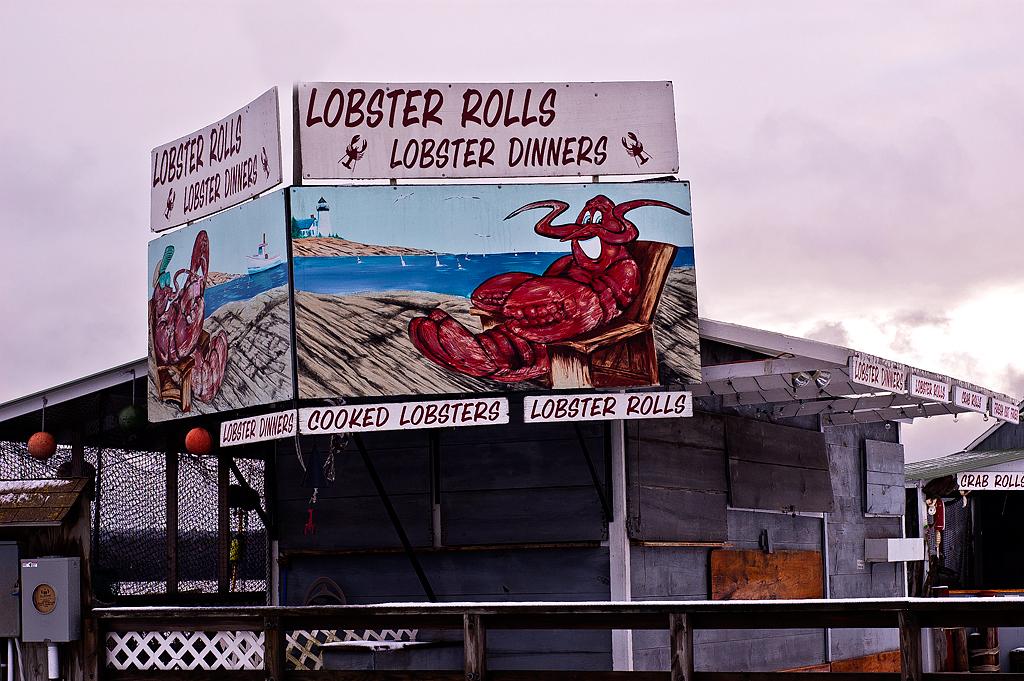What kind of rolls are offered?
Make the answer very short. Lobster. 